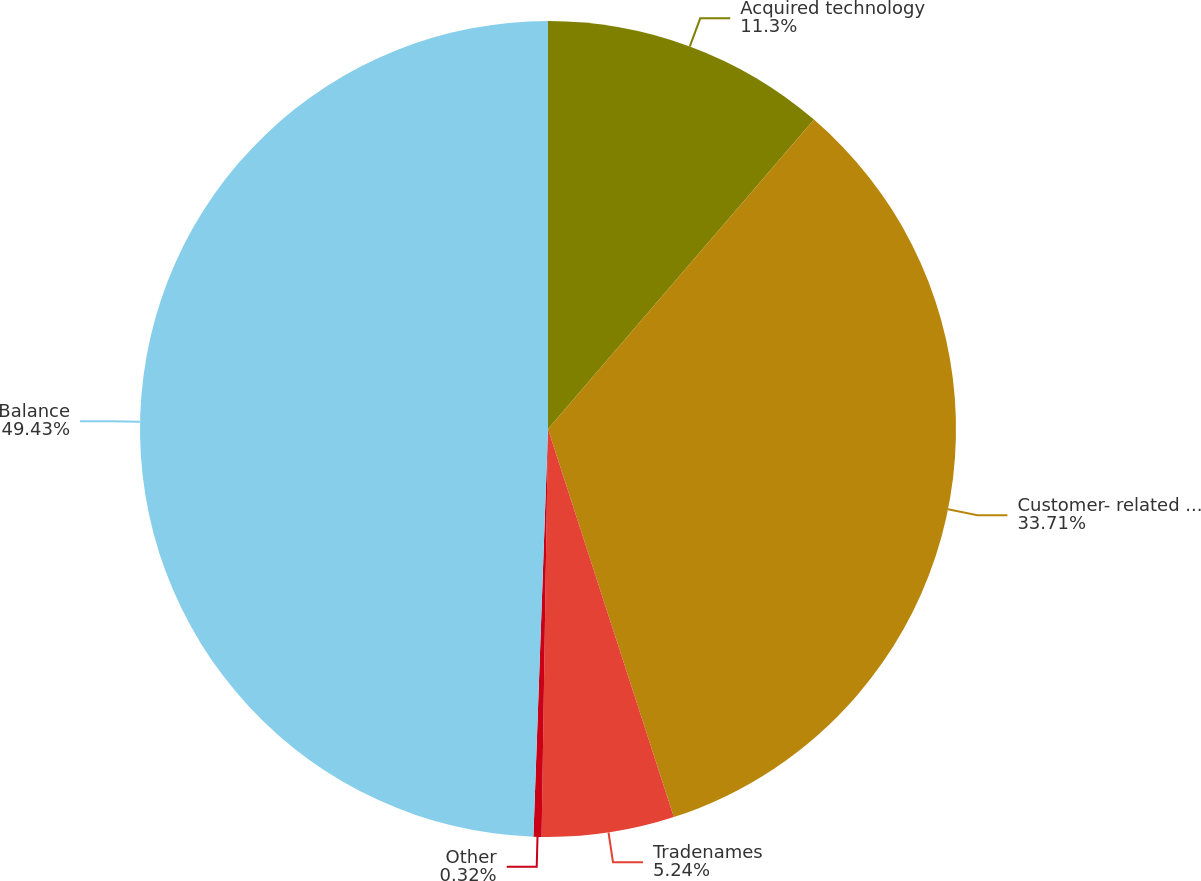Convert chart to OTSL. <chart><loc_0><loc_0><loc_500><loc_500><pie_chart><fcel>Acquired technology<fcel>Customer- related intangibles<fcel>Tradenames<fcel>Other<fcel>Balance<nl><fcel>11.3%<fcel>33.71%<fcel>5.24%<fcel>0.32%<fcel>49.43%<nl></chart> 